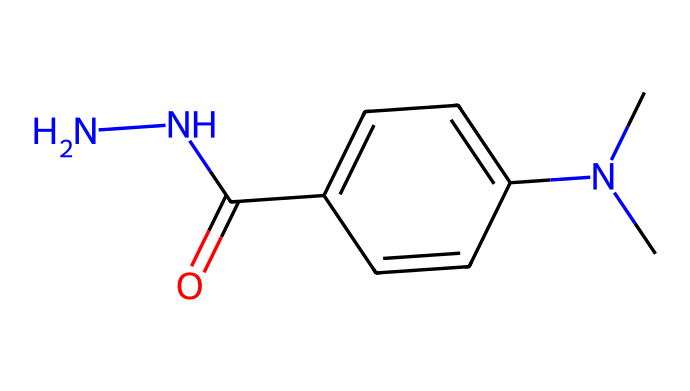What is the main functional group present in this chemical? The chemical contains a carbonyl group (C=O) as indicated by the notation "(=O)", which is characteristic of amides.
Answer: carbonyl How many nitrogen atoms are present in this structure? By examining the SMILES representation, we see two nitrogen atoms depicted by "N" at the beginning, indicating a hydrazine moiety.
Answer: two What type of substitution does the ring structure indicate? The presence of a substituent on the aromatic ring (shown by "c1ccc(...)) suggests that it's a mono-substituted aromatic compound, as only one such group (the hydrazine derivative in this case) is present.
Answer: mono-substituted Is this compound likely to be hydrophilic or hydrophobic? Given the presence of a hydrazine group (N-N) and an amide functional group (C(=O)N), the compound is likely to be hydrophilic due to these polar functional groups.
Answer: hydrophilic What role does the dimethyl group play in this chemical structure? The dimethyl group (N(C)C) contributes to steric effects and may affect the overall reactivity and biological activity of the molecule, which is common in hydrazine derivatives used in antidotes.
Answer: steric effects What kind of interactions might the terminal amine in the structure facilitate? The terminal amine (from the hydrazine part) can form hydrogen bonds due to its lone pair of electrons, contributing to interactions with biological molecules or solvation processes.
Answer: hydrogen bonds How many total bonds are present in the ring structure? By inspecting the ring in the SMILES (c1ccc(...)), each carbon in the aromatic part has alternating single and double bonds, suggesting a total of 4 bonds in the conjugated system (three single from C to C and one double between).
Answer: four 